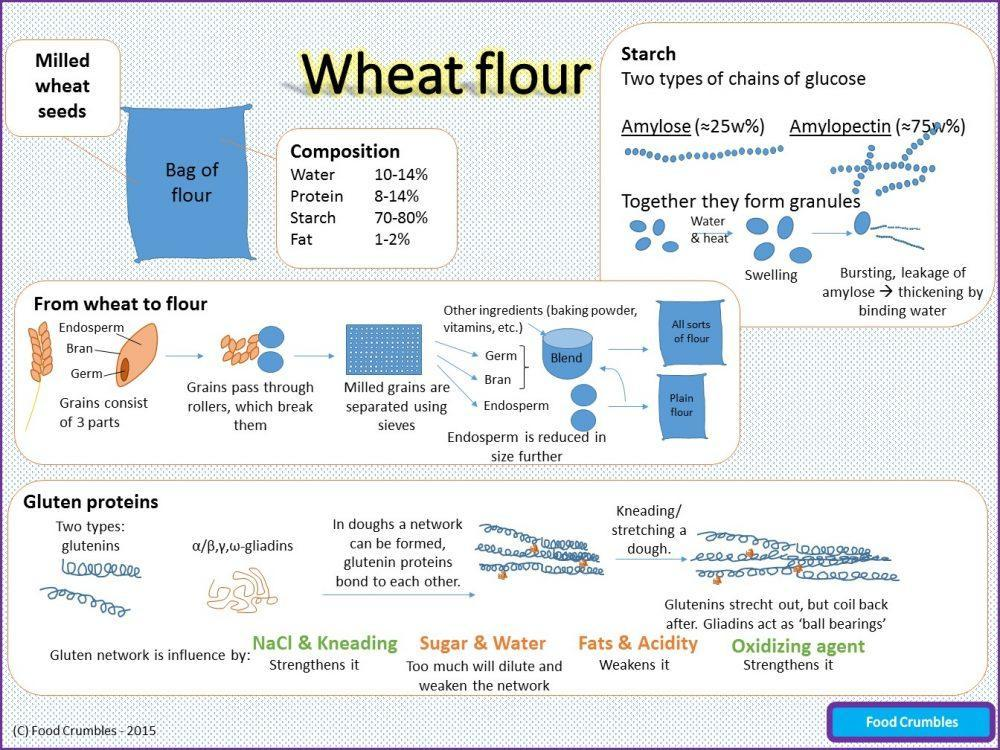What are the 3 parts of a grain
Answer the question with a short phrase. endosperm, bran, germ What all strengthens the gluten network NaCl & Kneading, Oxidizing agent What together form granules Amylose, Amylopectin too much of what will dilute and weaken the gluten network Sugar & Water 